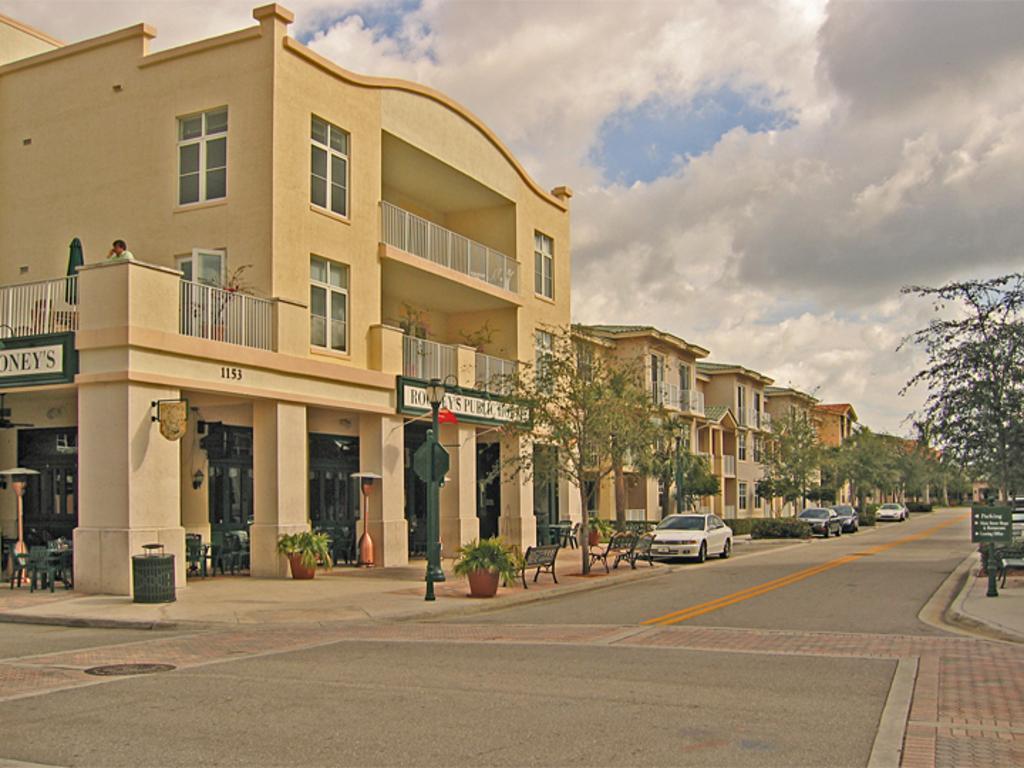How would you summarize this image in a sentence or two? In this picture we can see the sky with clouds. On the left side of the picture we can see the buildings, chairs, benches, trees and house plants. Near to the buildings we can see the cars. We can see poles and boards. On the right side of the picture we can see a tree and a board. At the bottom portion we can see the road and a drainage cap. We can see a person is standing in the balcony. 